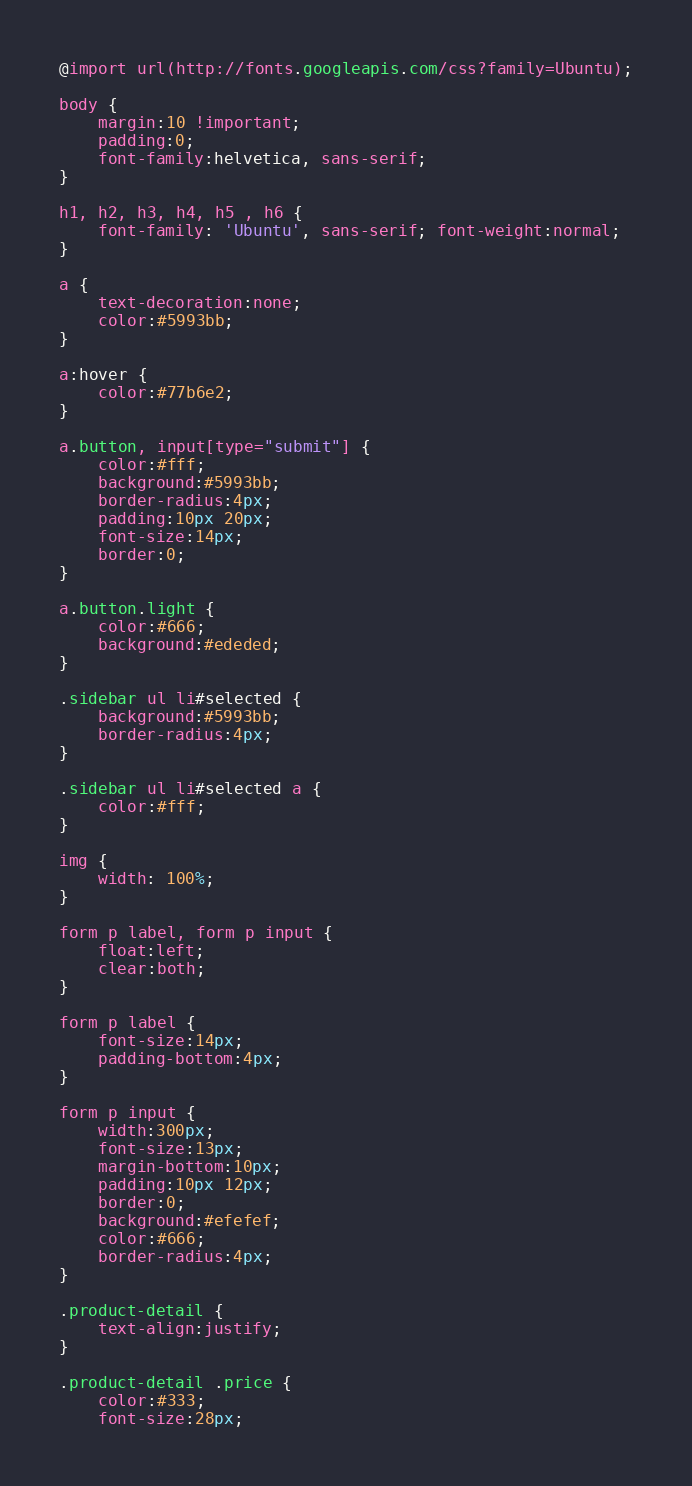Convert code to text. <code><loc_0><loc_0><loc_500><loc_500><_CSS_>@import url(http://fonts.googleapis.com/css?family=Ubuntu);

body { 
    margin:10 !important;
    padding:0;
    font-family:helvetica, sans-serif; 
}

h1, h2, h3, h4, h5 , h6 { 
    font-family: 'Ubuntu', sans-serif; font-weight:normal;
}

a {
    text-decoration:none;
    color:#5993bb;
}

a:hover {
    color:#77b6e2;
}

a.button, input[type="submit"] {
    color:#fff;
    background:#5993bb;
    border-radius:4px;
    padding:10px 20px;
    font-size:14px;
    border:0;
}

a.button.light {
    color:#666;
    background:#ededed;
}

.sidebar ul li#selected {
    background:#5993bb;
    border-radius:4px;
}

.sidebar ul li#selected a {
    color:#fff;
}

img {
	width: 100%;
}

form p label, form p input {
    float:left;
    clear:both;
}

form p label {
    font-size:14px;
    padding-bottom:4px;
}

form p input {
    width:300px;
    font-size:13px;
    margin-bottom:10px;
    padding:10px 12px;
    border:0;
    background:#efefef;
    color:#666;
    border-radius:4px;
}

.product-detail {
    text-align:justify;
}

.product-detail .price {
    color:#333;
    font-size:28px;</code> 